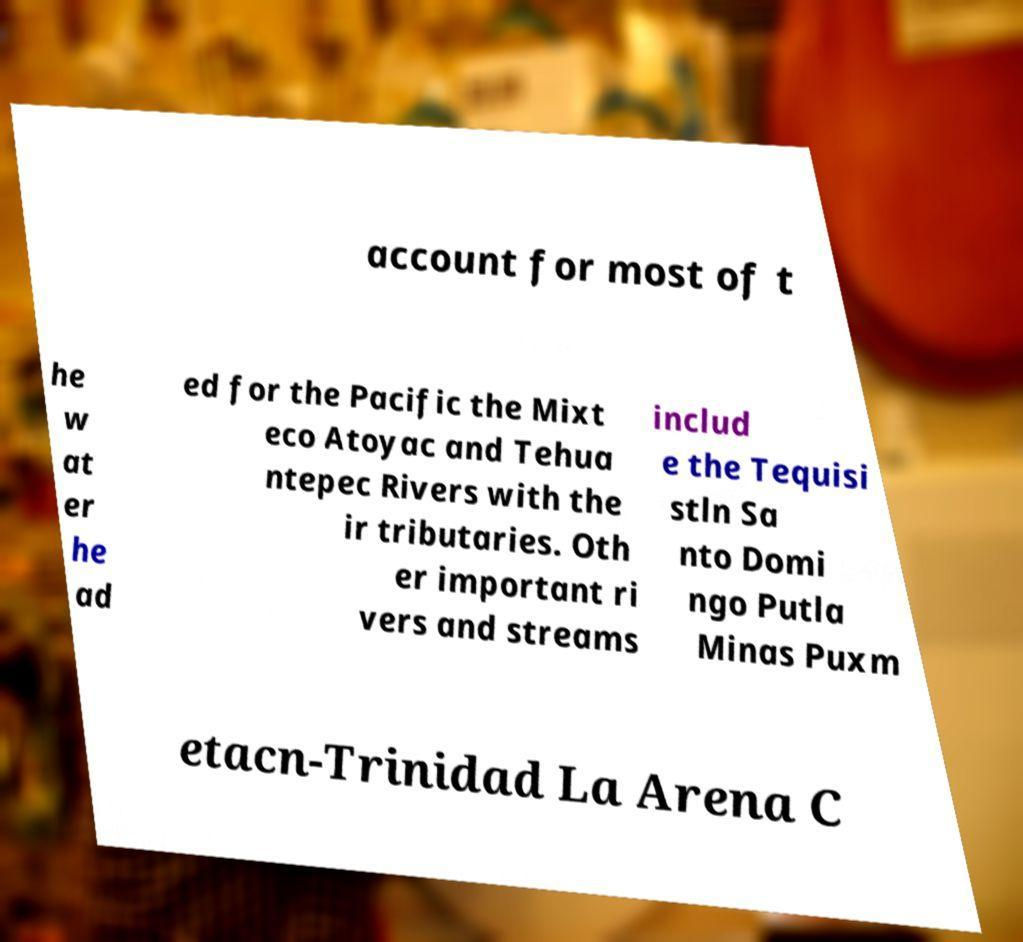Can you accurately transcribe the text from the provided image for me? account for most of t he w at er he ad ed for the Pacific the Mixt eco Atoyac and Tehua ntepec Rivers with the ir tributaries. Oth er important ri vers and streams includ e the Tequisi stln Sa nto Domi ngo Putla Minas Puxm etacn-Trinidad La Arena C 